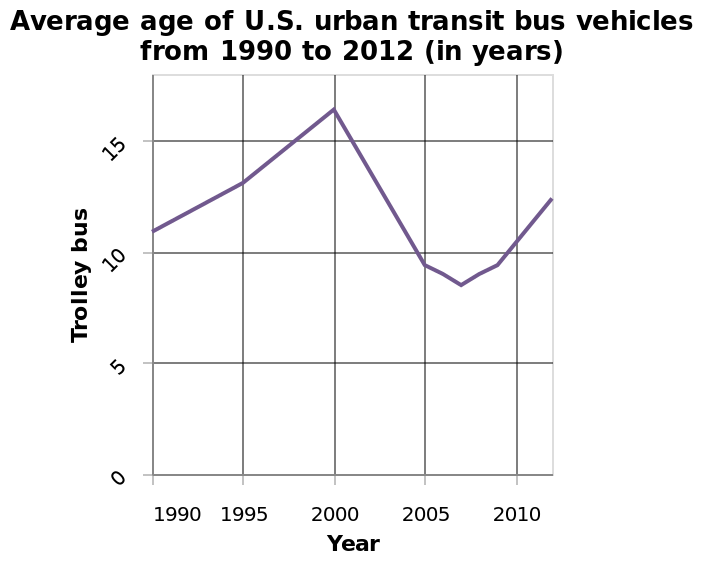<image>
Did the number of busses increase or decrease between 1990 and 2000?  The number of busses steadily increased from 1990 to 2000. 